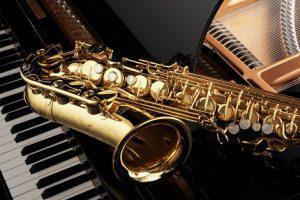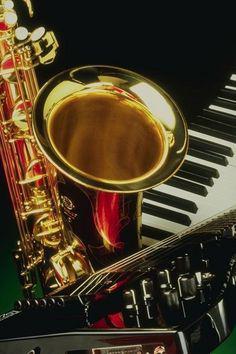The first image is the image on the left, the second image is the image on the right. For the images shown, is this caption "The only instruments shown are woodwinds." true? Answer yes or no. No. The first image is the image on the left, the second image is the image on the right. Given the left and right images, does the statement "At least one image includes a keyboard in a scene with a saxophone." hold true? Answer yes or no. Yes. 